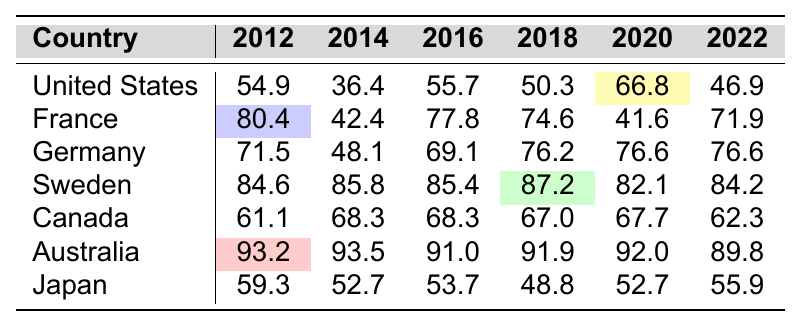What was the voter turnout rate in Canada in 2016? The table shows that the voter turnout rate in Canada for the year 2016 is 68.3.
Answer: 68.3 Which country had the highest voter turnout in 2012? From the table, Australia has the highest voter turnout rate in 2012 at 93.2.
Answer: Australia What was the average voter turnout rate for Sweden over the past decade? Adding the rates for Sweden from 2012 to 2022 gives: (84.6 + 85.8 + 85.4 + 87.2 + 82.1 + 84.2) = 509.3. Dividing this sum by 6 yields an average of 509.3 / 6 ≈ 84.9.
Answer: 84.9 Did voter turnout in the United States increase or decrease from 2016 to 2020? The table indicates that the turnout in the United States was 55.7 in 2016 and increased to 66.8 in 2020. Therefore, it increased.
Answer: Increased Which country had the lowest voter turnout in 2018? The table shows that Japan had the lowest voter turnout in 2018 at 48.8.
Answer: Japan What is the difference in voter turnout between Germany in 2014 and 2018? The voter turnout in Germany for 2014 was 48.1, and for 2018 it was 76.2. The difference is 76.2 - 48.1 = 28.1.
Answer: 28.1 What country saw the most significant decline in voter turnout from 2012 to 2022? By looking at the percentages: United States decreased from 54.9 to 46.9 (7.9), France from 80.4 to 71.9 (8.5), Germany remained the same at 76.6, Sweden from 84.6 to 84.2 (0.4), Canada from 61.1 to 62.3 (0.8), Australia from 93.2 to 89.8 (3.4), and Japan from 59.3 to 55.9 (3.4). The largest decline is in France (8.5).
Answer: France What was the trend of voter turnout rates for Australia over the past decade? By observing the table, the rates for Australia have shown a general decrease from 93.2 in 2012 to 89.8 in 2022, indicating a downward trend.
Answer: Downward trend How does the voter turnout in 2020 compare across the listed countries? The turnout rates of countries for 2020 are: United States (66.8), France (41.6), Germany (76.6), Sweden (82.1), Canada (67.7), Australia (92.0), and Japan (52.7). Among these, Australia had the highest turnout at 92.0 while France had the lowest at 41.6.
Answer: Australia had the highest, France had the lowest Is the voter turnout rate for France in 2020 higher than that for Germany in the same year? The table shows that France's turnout in 2020 was 41.6 while Germany's was 76.6. Since 41.6 is lower than 76.6, the statement is false.
Answer: No 